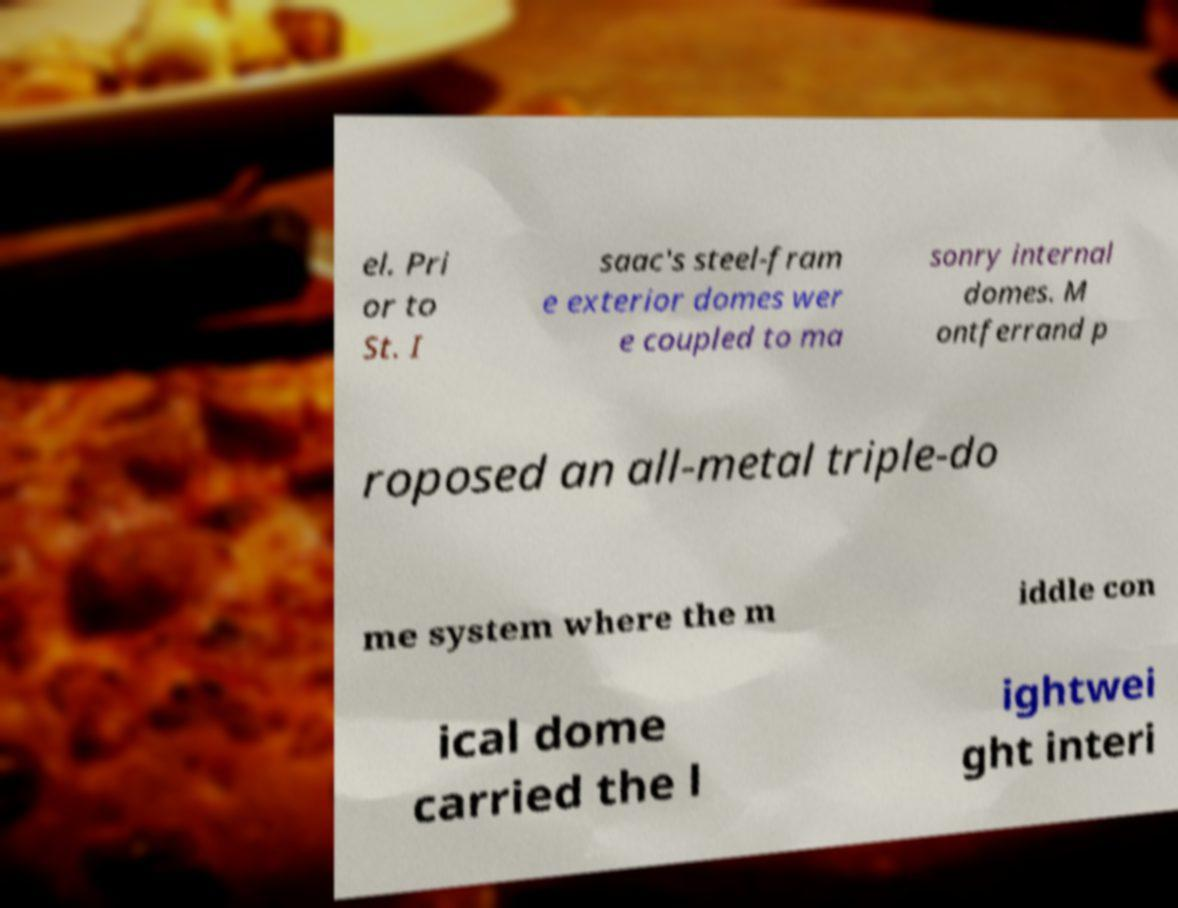Please identify and transcribe the text found in this image. el. Pri or to St. I saac's steel-fram e exterior domes wer e coupled to ma sonry internal domes. M ontferrand p roposed an all-metal triple-do me system where the m iddle con ical dome carried the l ightwei ght interi 